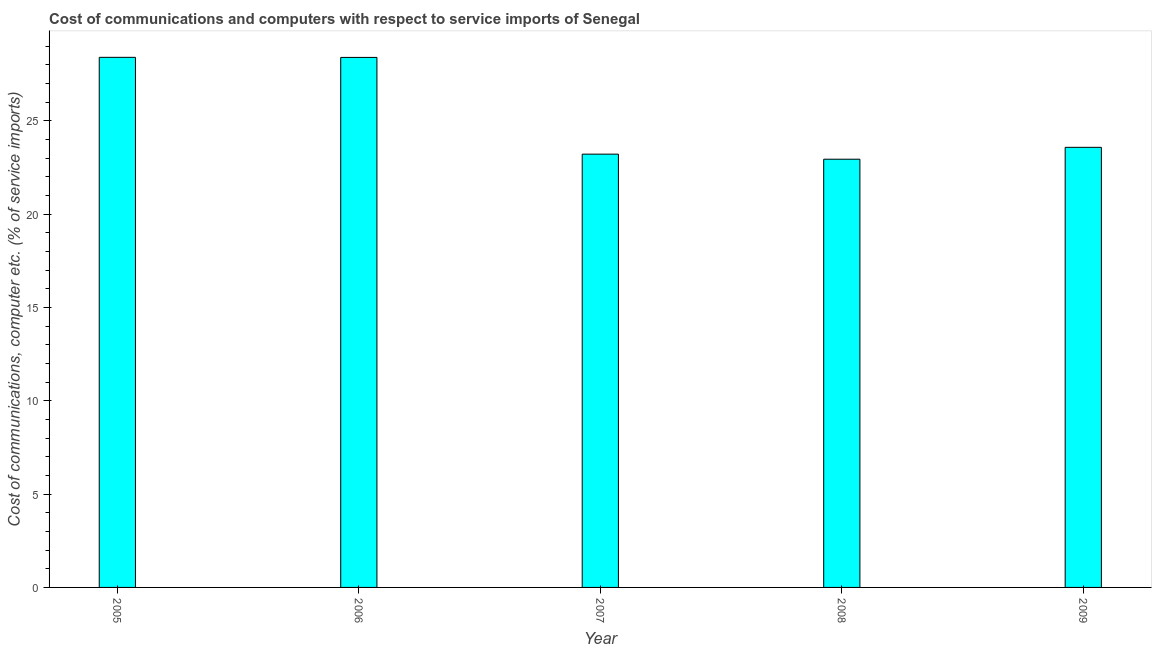Does the graph contain any zero values?
Give a very brief answer. No. What is the title of the graph?
Ensure brevity in your answer.  Cost of communications and computers with respect to service imports of Senegal. What is the label or title of the Y-axis?
Your answer should be compact. Cost of communications, computer etc. (% of service imports). What is the cost of communications and computer in 2008?
Your response must be concise. 22.94. Across all years, what is the maximum cost of communications and computer?
Make the answer very short. 28.4. Across all years, what is the minimum cost of communications and computer?
Give a very brief answer. 22.94. In which year was the cost of communications and computer maximum?
Give a very brief answer. 2005. What is the sum of the cost of communications and computer?
Your answer should be compact. 126.51. What is the difference between the cost of communications and computer in 2005 and 2006?
Provide a succinct answer. 0.01. What is the average cost of communications and computer per year?
Ensure brevity in your answer.  25.3. What is the median cost of communications and computer?
Your response must be concise. 23.57. In how many years, is the cost of communications and computer greater than 18 %?
Offer a very short reply. 5. Do a majority of the years between 2007 and 2005 (inclusive) have cost of communications and computer greater than 1 %?
Keep it short and to the point. Yes. Is the cost of communications and computer in 2006 less than that in 2009?
Your answer should be very brief. No. What is the difference between the highest and the second highest cost of communications and computer?
Your answer should be compact. 0.01. Is the sum of the cost of communications and computer in 2005 and 2006 greater than the maximum cost of communications and computer across all years?
Your answer should be very brief. Yes. What is the difference between the highest and the lowest cost of communications and computer?
Ensure brevity in your answer.  5.46. Are all the bars in the graph horizontal?
Make the answer very short. No. How many years are there in the graph?
Ensure brevity in your answer.  5. What is the difference between two consecutive major ticks on the Y-axis?
Offer a terse response. 5. Are the values on the major ticks of Y-axis written in scientific E-notation?
Offer a terse response. No. What is the Cost of communications, computer etc. (% of service imports) of 2005?
Provide a short and direct response. 28.4. What is the Cost of communications, computer etc. (% of service imports) of 2006?
Make the answer very short. 28.39. What is the Cost of communications, computer etc. (% of service imports) of 2007?
Offer a very short reply. 23.21. What is the Cost of communications, computer etc. (% of service imports) in 2008?
Offer a terse response. 22.94. What is the Cost of communications, computer etc. (% of service imports) in 2009?
Make the answer very short. 23.57. What is the difference between the Cost of communications, computer etc. (% of service imports) in 2005 and 2006?
Make the answer very short. 0. What is the difference between the Cost of communications, computer etc. (% of service imports) in 2005 and 2007?
Offer a terse response. 5.19. What is the difference between the Cost of communications, computer etc. (% of service imports) in 2005 and 2008?
Your answer should be compact. 5.46. What is the difference between the Cost of communications, computer etc. (% of service imports) in 2005 and 2009?
Your answer should be very brief. 4.82. What is the difference between the Cost of communications, computer etc. (% of service imports) in 2006 and 2007?
Give a very brief answer. 5.18. What is the difference between the Cost of communications, computer etc. (% of service imports) in 2006 and 2008?
Your answer should be very brief. 5.45. What is the difference between the Cost of communications, computer etc. (% of service imports) in 2006 and 2009?
Make the answer very short. 4.82. What is the difference between the Cost of communications, computer etc. (% of service imports) in 2007 and 2008?
Make the answer very short. 0.27. What is the difference between the Cost of communications, computer etc. (% of service imports) in 2007 and 2009?
Ensure brevity in your answer.  -0.36. What is the difference between the Cost of communications, computer etc. (% of service imports) in 2008 and 2009?
Ensure brevity in your answer.  -0.64. What is the ratio of the Cost of communications, computer etc. (% of service imports) in 2005 to that in 2006?
Make the answer very short. 1. What is the ratio of the Cost of communications, computer etc. (% of service imports) in 2005 to that in 2007?
Provide a short and direct response. 1.22. What is the ratio of the Cost of communications, computer etc. (% of service imports) in 2005 to that in 2008?
Keep it short and to the point. 1.24. What is the ratio of the Cost of communications, computer etc. (% of service imports) in 2005 to that in 2009?
Your response must be concise. 1.21. What is the ratio of the Cost of communications, computer etc. (% of service imports) in 2006 to that in 2007?
Provide a short and direct response. 1.22. What is the ratio of the Cost of communications, computer etc. (% of service imports) in 2006 to that in 2008?
Your answer should be very brief. 1.24. What is the ratio of the Cost of communications, computer etc. (% of service imports) in 2006 to that in 2009?
Your answer should be compact. 1.2. What is the ratio of the Cost of communications, computer etc. (% of service imports) in 2007 to that in 2009?
Your answer should be compact. 0.98. What is the ratio of the Cost of communications, computer etc. (% of service imports) in 2008 to that in 2009?
Your answer should be compact. 0.97. 